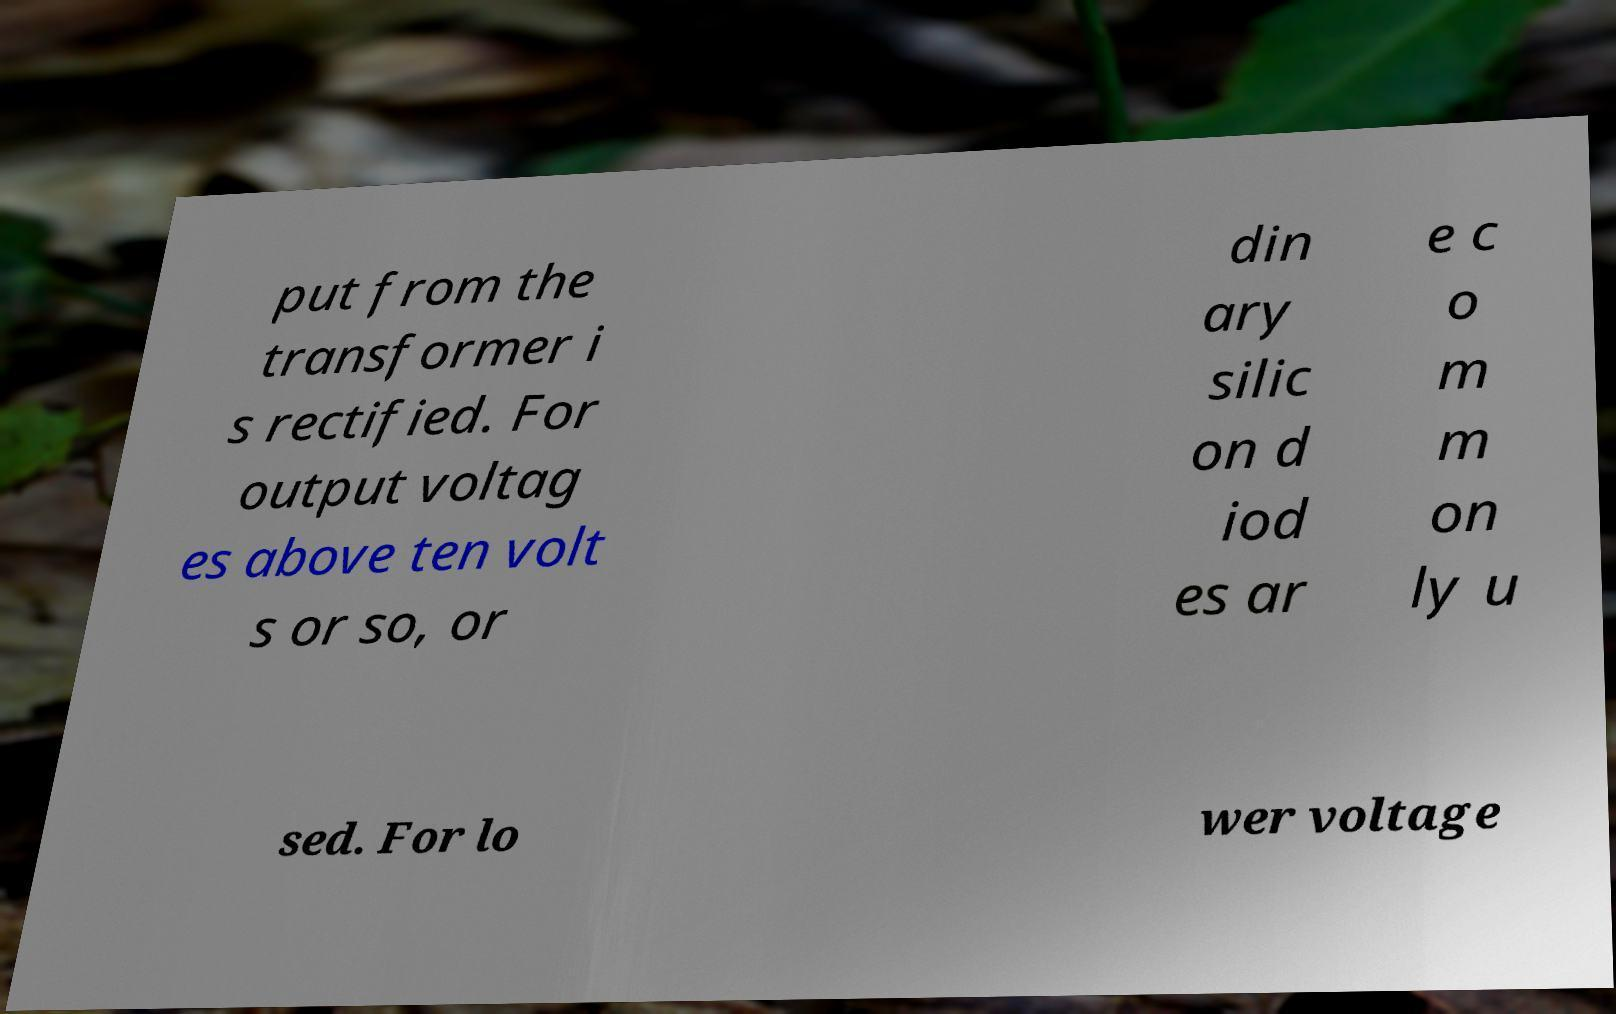Can you read and provide the text displayed in the image?This photo seems to have some interesting text. Can you extract and type it out for me? put from the transformer i s rectified. For output voltag es above ten volt s or so, or din ary silic on d iod es ar e c o m m on ly u sed. For lo wer voltage 